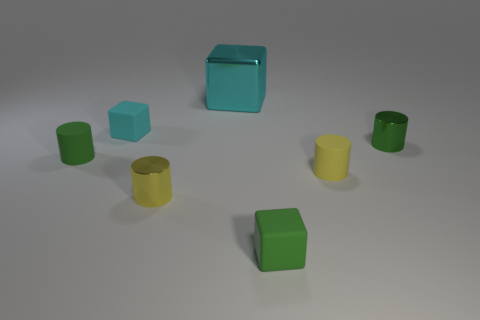Add 2 large red metallic cylinders. How many objects exist? 9 Subtract all blocks. How many objects are left? 4 Subtract 1 cyan blocks. How many objects are left? 6 Subtract all large blue things. Subtract all yellow things. How many objects are left? 5 Add 2 small yellow metal cylinders. How many small yellow metal cylinders are left? 3 Add 7 tiny brown cylinders. How many tiny brown cylinders exist? 7 